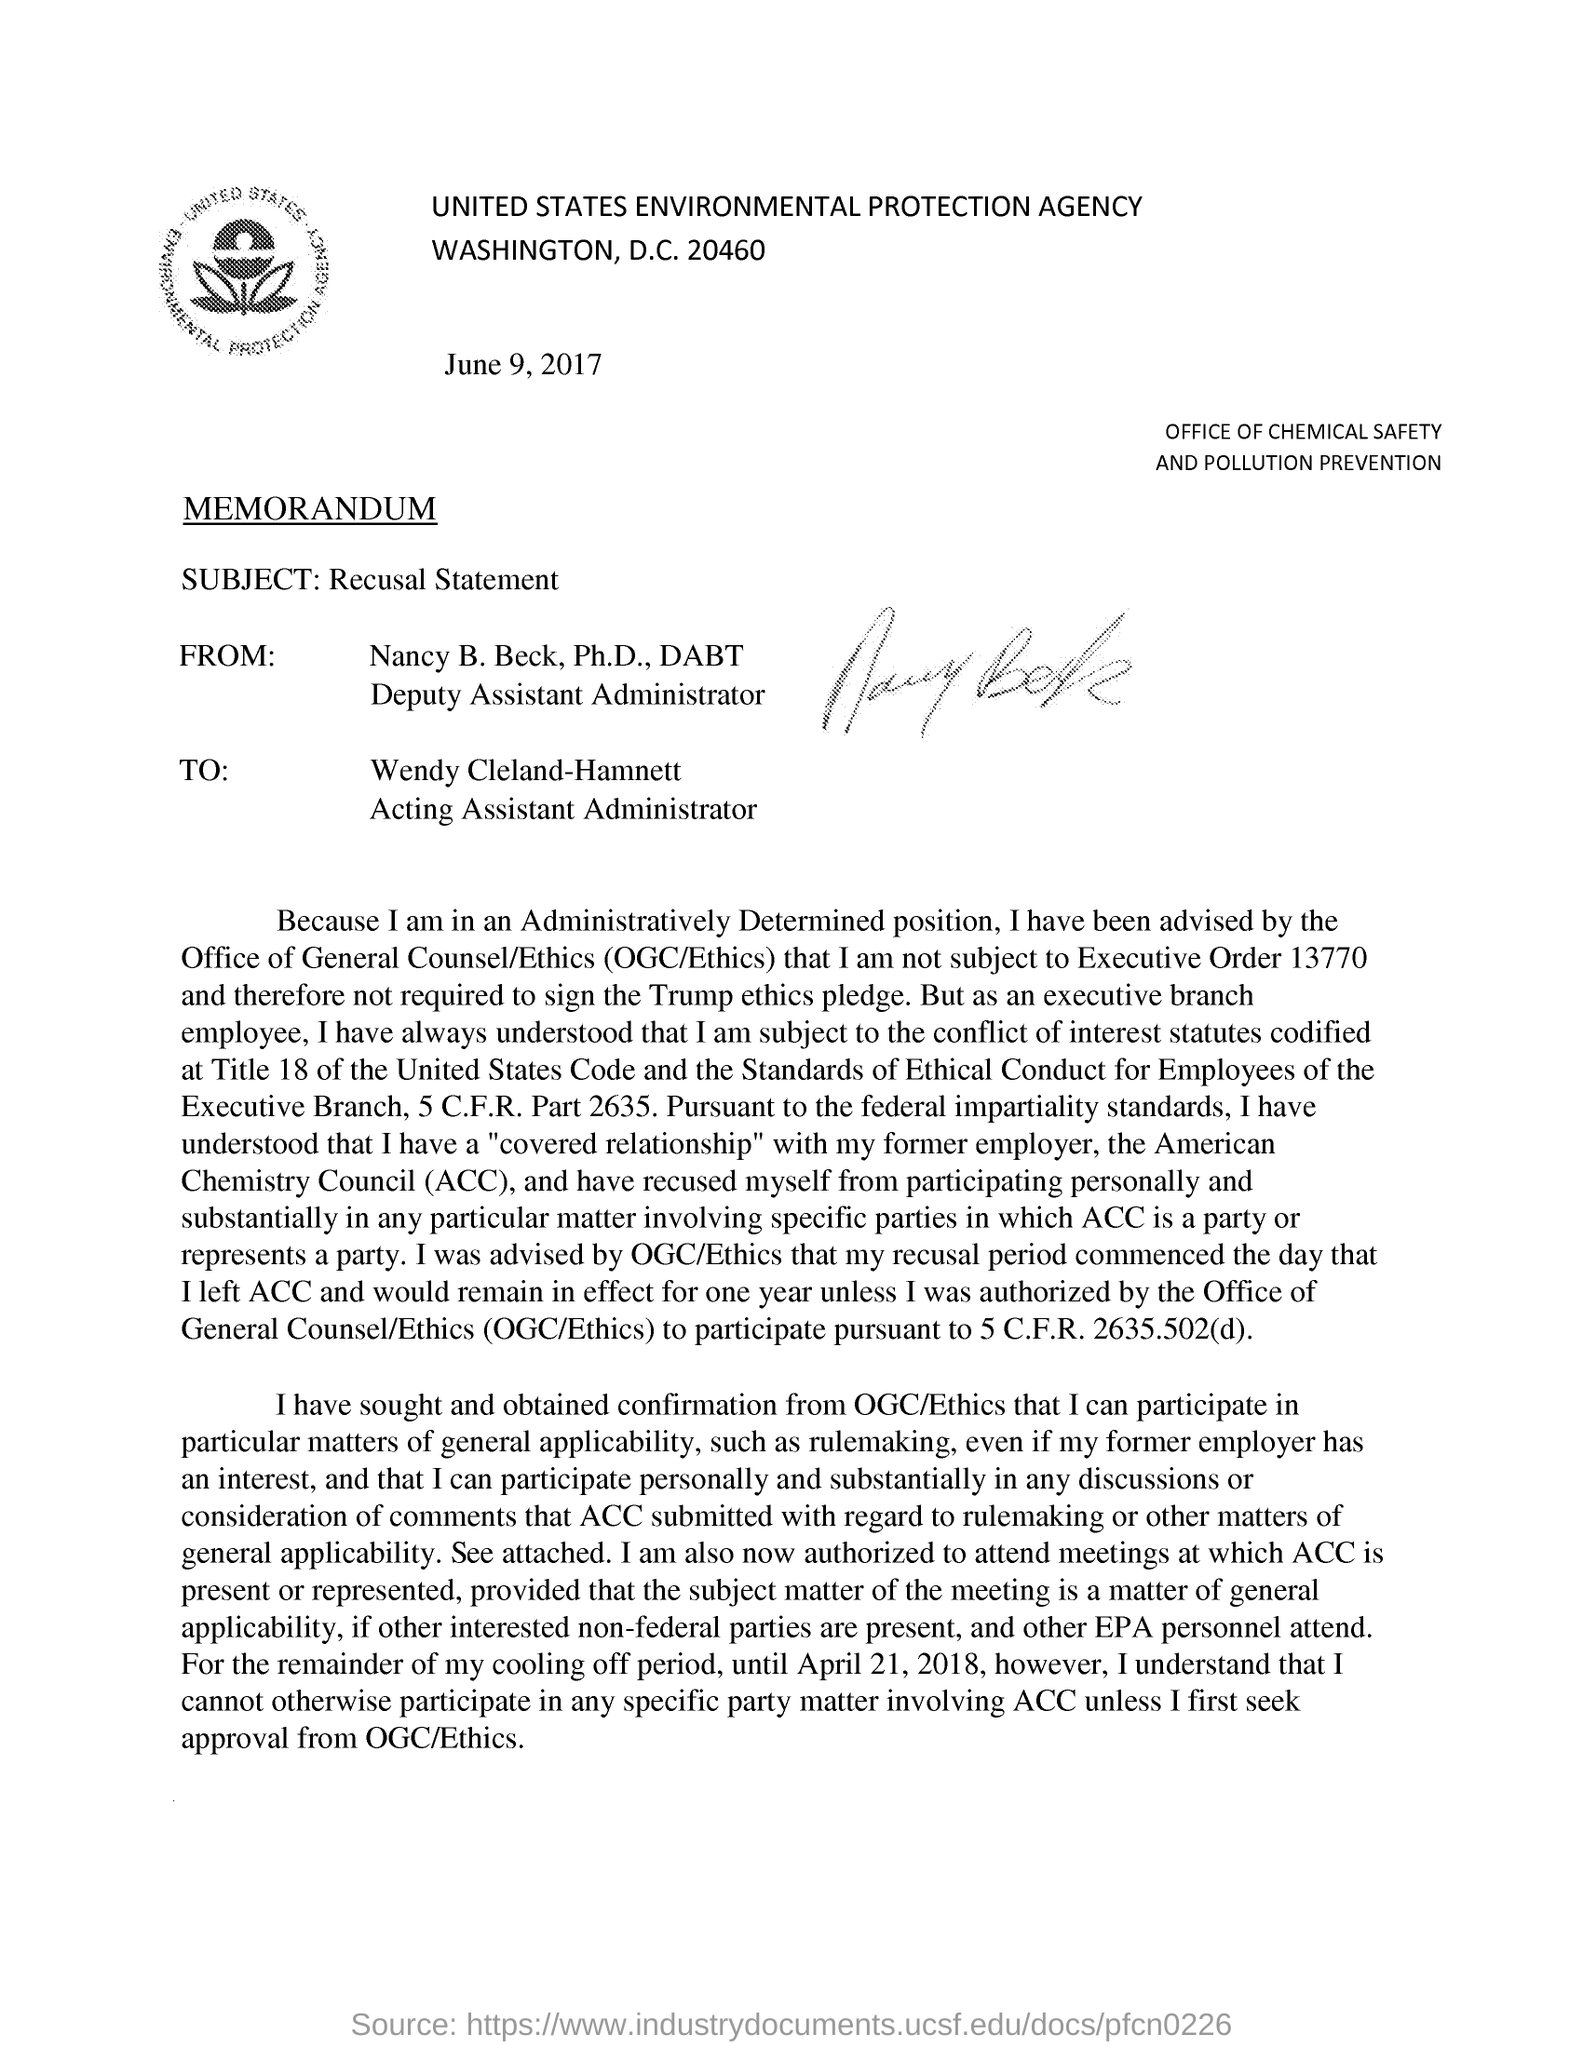Point out several critical features in this image. The subject of the memorandum is a declaration of recusal. This document is addressed to Wendy Cleland-Hamnett. Nancy B. Beck, Ph.D., DABT, wrote this document. 